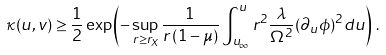Convert formula to latex. <formula><loc_0><loc_0><loc_500><loc_500>\kappa ( u , v ) \geq \frac { 1 } { 2 } \exp \left ( - \sup _ { r \geq r _ { X } } { \frac { 1 } { r \left ( 1 - \mu \right ) } } \int ^ { u } _ { u _ { \infty } } r ^ { 2 } \frac { \lambda } { \Omega ^ { 2 } } ( \partial _ { u } \phi ) ^ { 2 } d u \right ) \, .</formula> 